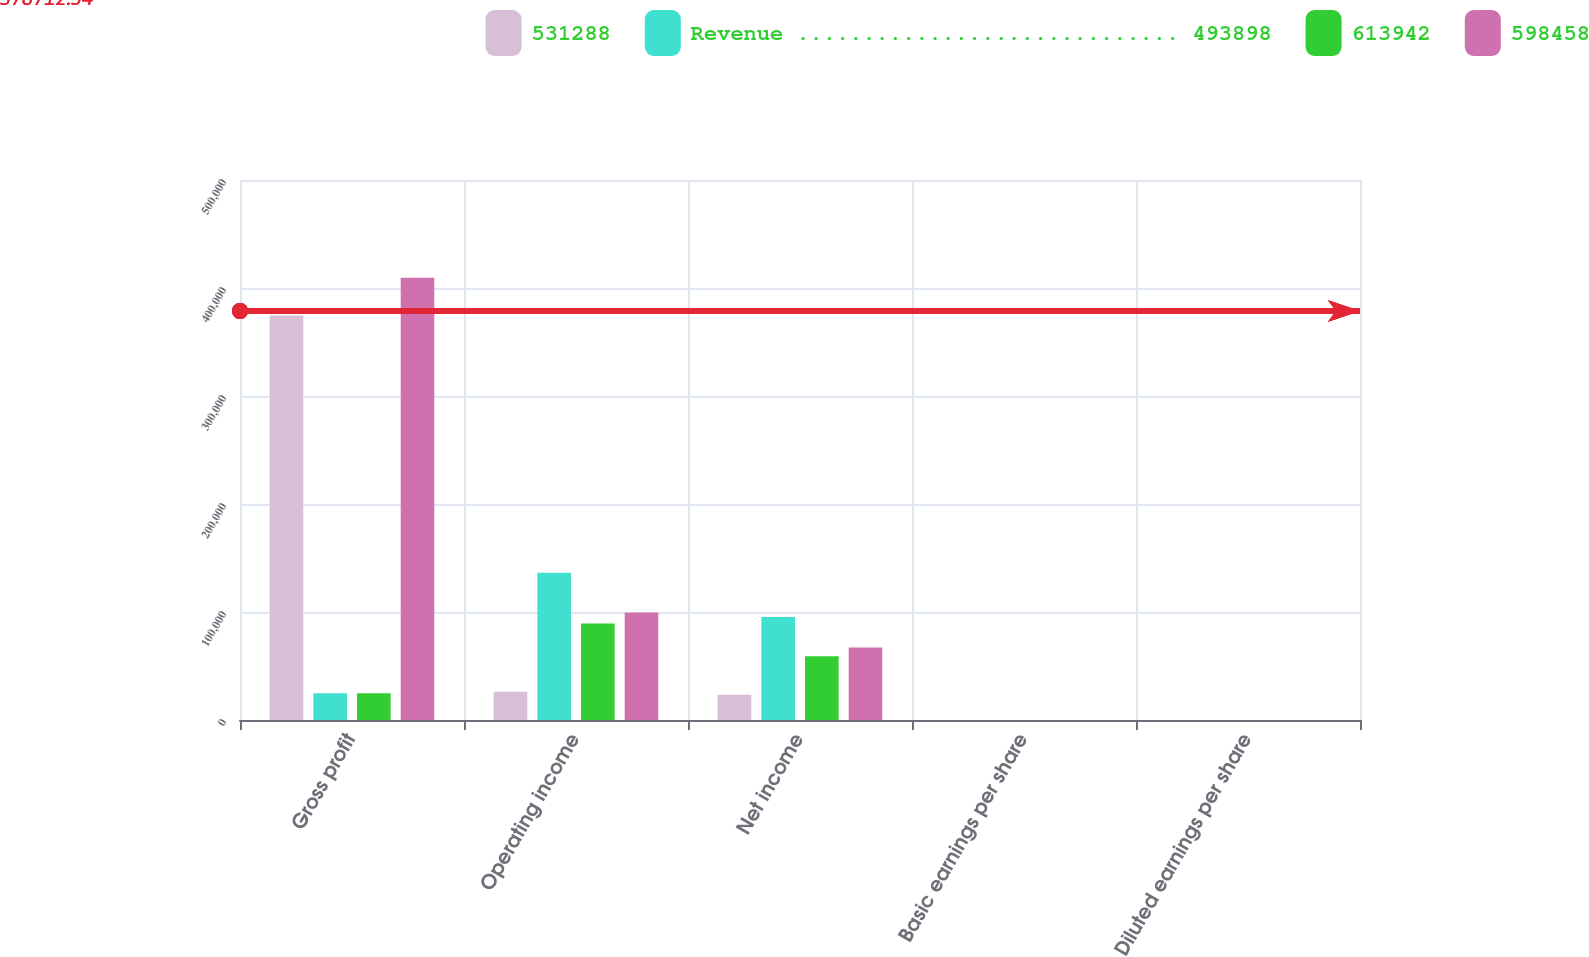Convert chart. <chart><loc_0><loc_0><loc_500><loc_500><stacked_bar_chart><ecel><fcel>Gross profit<fcel>Operating income<fcel>Net income<fcel>Basic earnings per share<fcel>Diluted earnings per share<nl><fcel>531288<fcel>374584<fcel>26242<fcel>23335<fcel>0.07<fcel>0.06<nl><fcel>Revenue ............................. 493898<fcel>24788.5<fcel>136255<fcel>95482<fcel>0.28<fcel>0.27<nl><fcel>613942<fcel>24788.5<fcel>89292<fcel>58977<fcel>0.18<fcel>0.17<nl><fcel>598458<fcel>409507<fcel>99540<fcel>67140<fcel>0.2<fcel>0.2<nl></chart> 